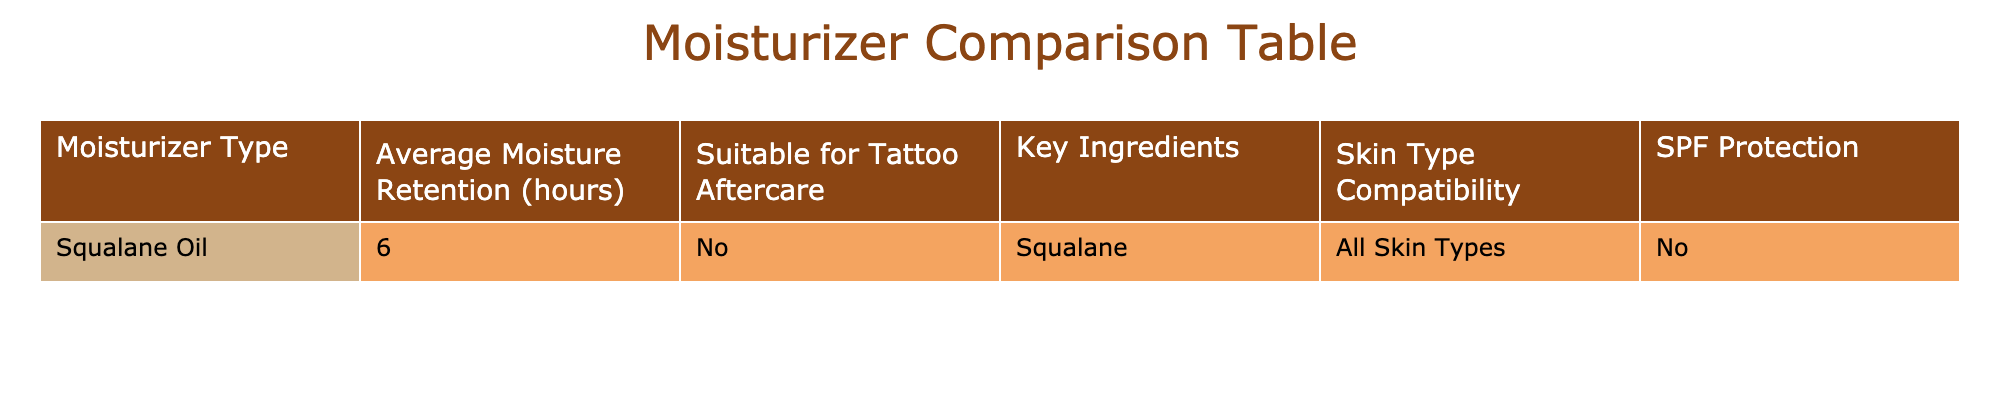What is the average moisture retention for Squalane Oil? The table lists the average moisture retention for Squalane Oil as 6 hours, which is stated directly in the relevant column.
Answer: 6 hours Is Squalane Oil suitable for tattoo aftercare? The table indicates that Squalane Oil is marked as "No" under the column for suitability for tattoo aftercare, making it clear that it is not recommended for this purpose.
Answer: No What key ingredient is found in Squalane Oil? Referring to the table, the key ingredient specifically mentioned for Squalane Oil is "Squalane," which is stated under the Key Ingredients column.
Answer: Squalane How many hours of moisture retention do products with SPF protection have? Since the table indicates that Squalane Oil has no SPF protection and lists 6 hours for moisture retention, the average for moisturizers with SPF protection is not possible to derive from this dataset, which contains only one entry. Therefore, we conclude that there is no applicable data.
Answer: No applicable data available Is Squalane Oil compatible with all skin types? The table confirms that Squalane Oil is compatible with "All Skin Types," which is stated in the Skin Type Compatibility column.
Answer: Yes What is the moisture retention difference between Squalane Oil and a hypothetical moisturizer with 8 hours of retention? Since Squalane Oil has an average moisture retention of 6 hours, the difference between Squalane Oil and a hypothetical moisturizer that retains moisture for 8 hours would be calculated as 8 - 6 = 2 hours. Therefore, it's a 2-hour difference in moisture retention.
Answer: 2 hours How does the average moisture retention of Squalane Oil compare to typical values for moisturizers with SPF? The table does not provide data on any moisturizers with SPF protection, so we cannot perform a direct comparison regarding their average moisture retention time. Therefore, we cannot conclude anything about their difference, as Squalane Oil is the only entry presented.
Answer: No comparison possible Is there a moisturizer listed that provides both moisture retention and SPF protection? Based on the table, there are no entries indicating a moisturizer that provides moisture retention along with SPF protection, as Squalane Oil has no SPF declared, leading us to conclude that none are listed.
Answer: No 